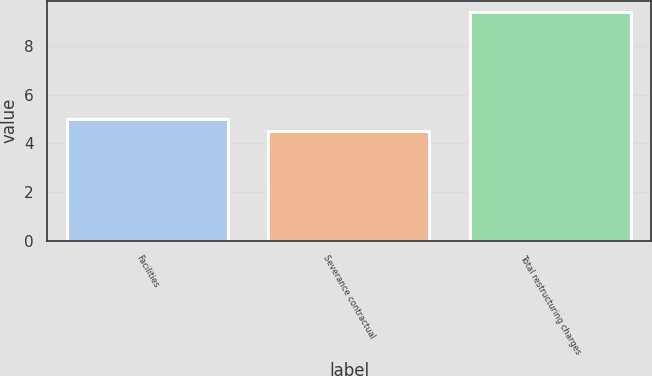Convert chart. <chart><loc_0><loc_0><loc_500><loc_500><bar_chart><fcel>Facilities<fcel>Severance contractual<fcel>Total restructuring charges<nl><fcel>4.99<fcel>4.5<fcel>9.4<nl></chart> 